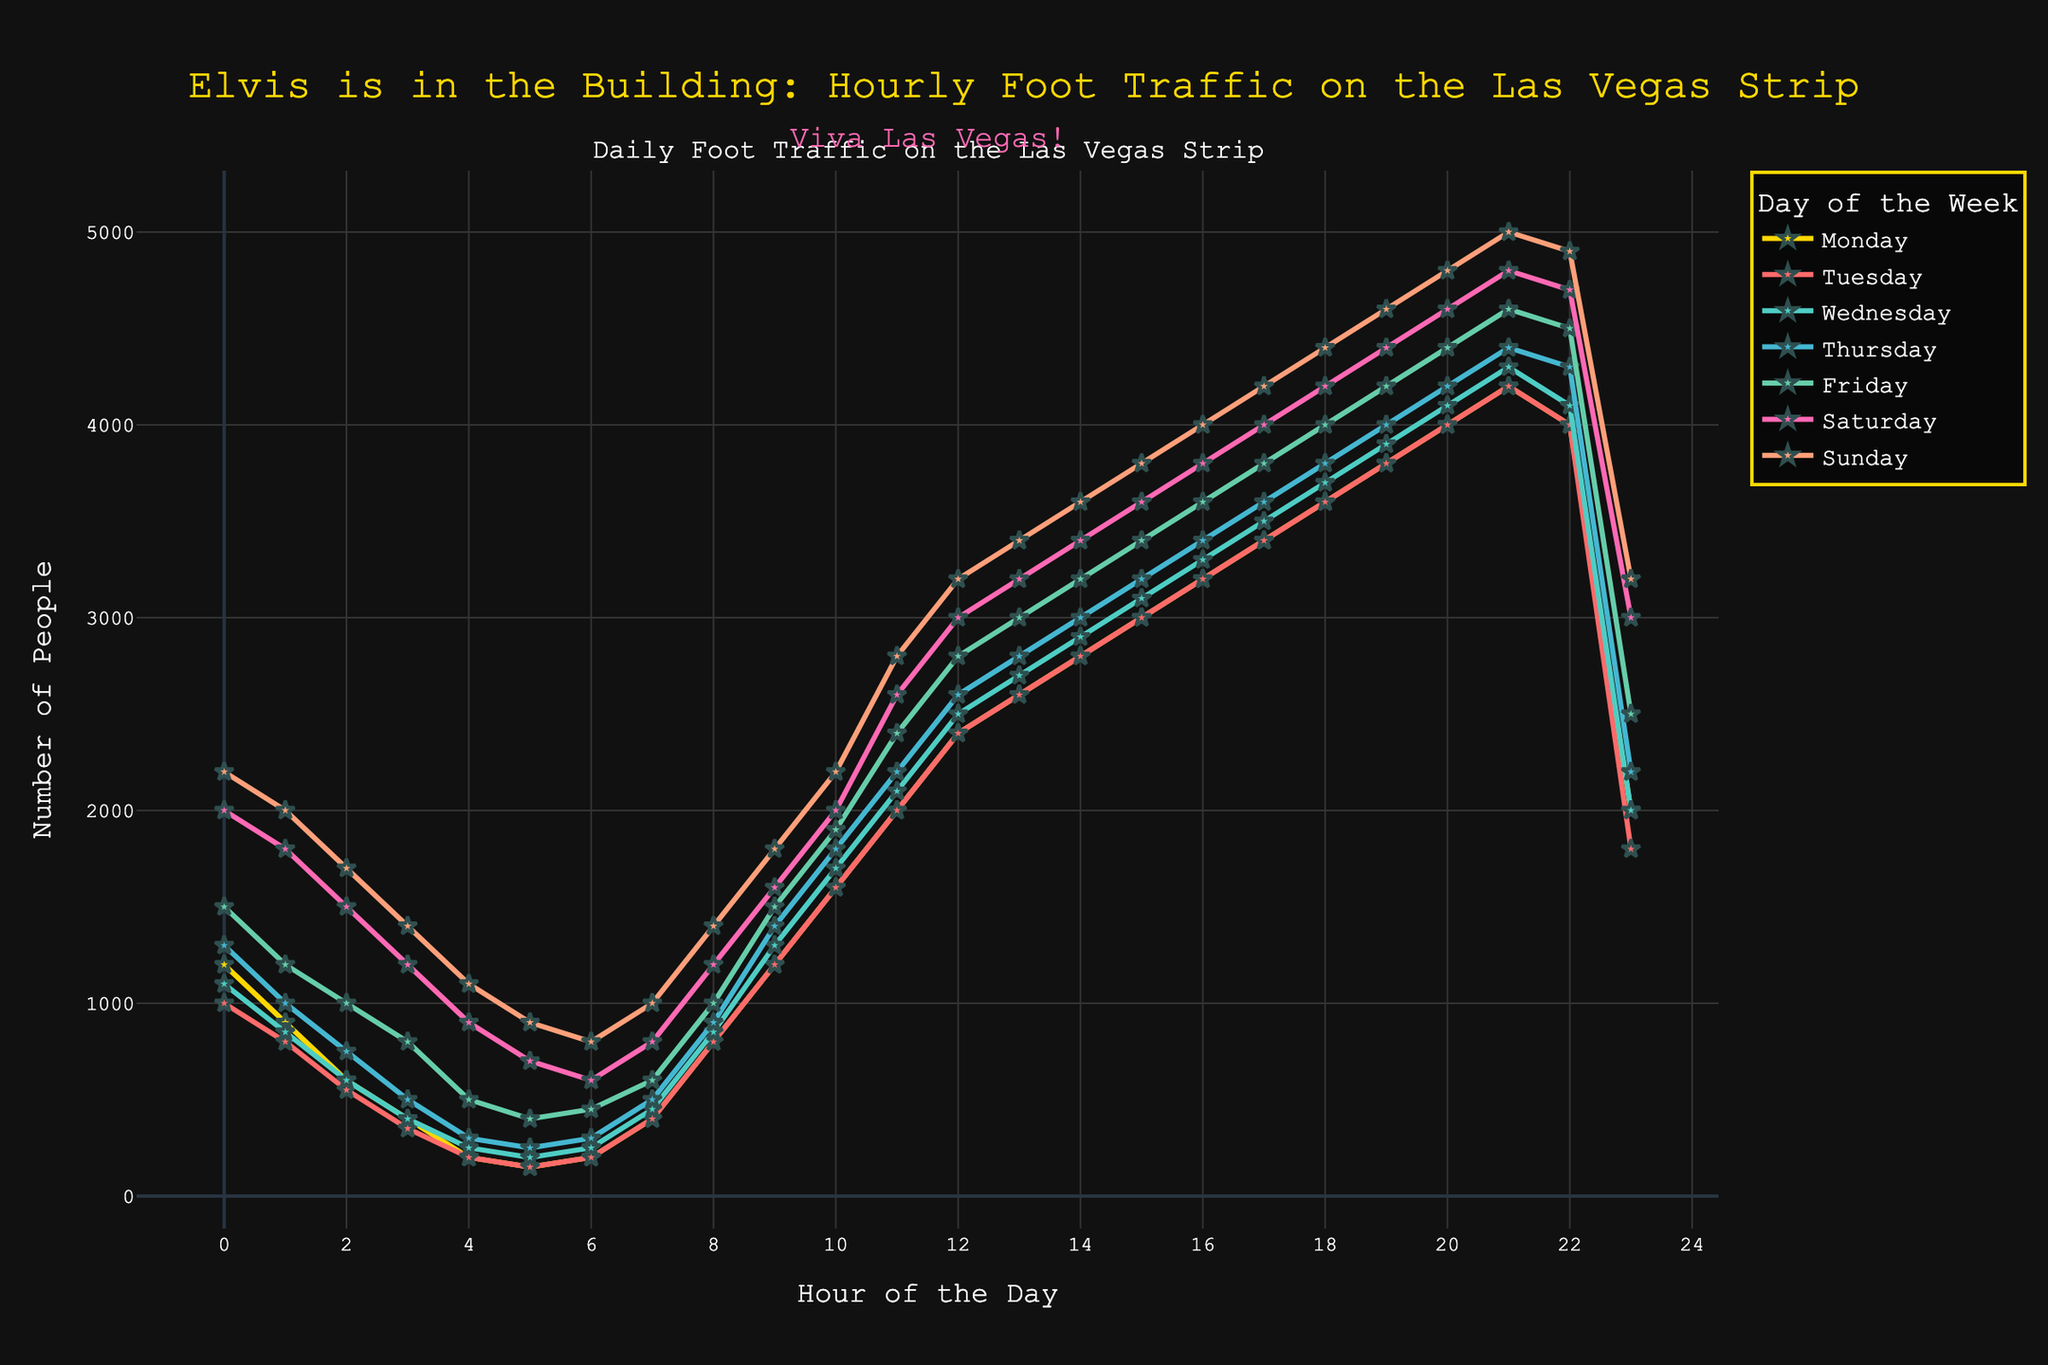What's the busiest hour on Saturday? To determine the busiest hour on Saturday, locate the highest point on the line corresponding to Saturday's data. The peak value is at 21:00 (4800 people).
Answer: 21:00 Which day has the highest maximum foot traffic and at what hour? Refer to each line graph and note the maximum value for each day. The highest is on Sunday at 21:00 (5000 people).
Answer: Sunday at 21:00 Compare the foot traffic at 10:00 on Monday and Thursday. Which is higher and by how much? Check the foot traffic values at 10:00. On Monday, it's 1600, and on Thursday, it's 1800. The difference is 200 more on Thursday.
Answer: Thursday by 200 What is the average foot traffic at 17:00 from Monday to Friday? Add the foot traffic at 17:00 from Monday (3400), Tuesday (3400), Wednesday (3500), Thursday (3600), and Friday (3800). Then, divide by 5. Average = (3400+3400+3500+3600+3800) / 5 = 3540.
Answer: 3540 At what hour does Tuesday's foot traffic first exceed 4000? Look at the line for Tuesday and find the first hour it exceeds 4000. It's at 19:00.
Answer: 19:00 How does the foot traffic at 22:00 on Wednesday compare to the same hour on Friday? Observe the values at 22:00. On Wednesday, it's 4100, and on Friday, it's 4500. 4500 is higher than 4100 by 400.
Answer: Friday is higher by 400 Which day has the lowest foot traffic at 3:00? Compare the values at 3:00 across all days. The lowest is Monday at 400.
Answer: Monday Is the foot traffic at 12:00 on Saturday higher or lower than the same time on Sunday, and by how much? Check the values at 12:00. On Saturday, it's 3000. On Sunday, it's 3200. The difference is 200.
Answer: Sunday by 200 What's the total foot traffic for Monday between 11:00 and 13:00? Sum the values from 11:00 to 13:00 on Monday. 2000 (11:00) + 2400 (12:00) + 2600 (13:00) = 7000.
Answer: 7000 What is the difference in foot traffic between 0:00 and 23:00 on Sunday? Compare the values at 0:00 (2200) and 23:00 (3200). The difference is 3200 - 2200 = 1000.
Answer: 1000 